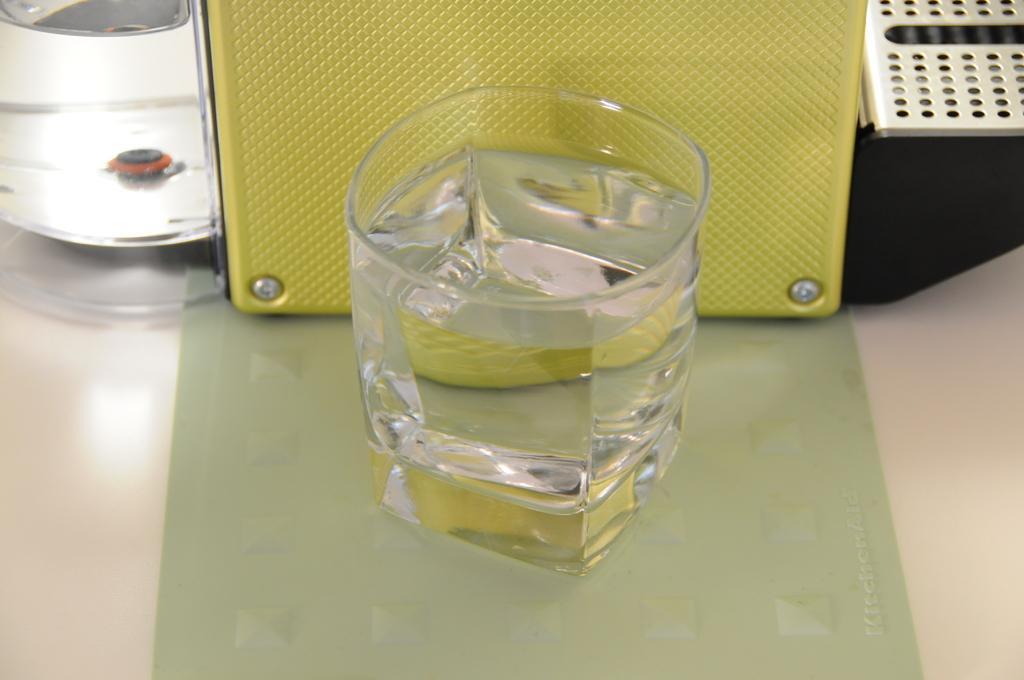Please provide a concise description of this image. In this picture we can see the water gales, some boxes are on the table. 